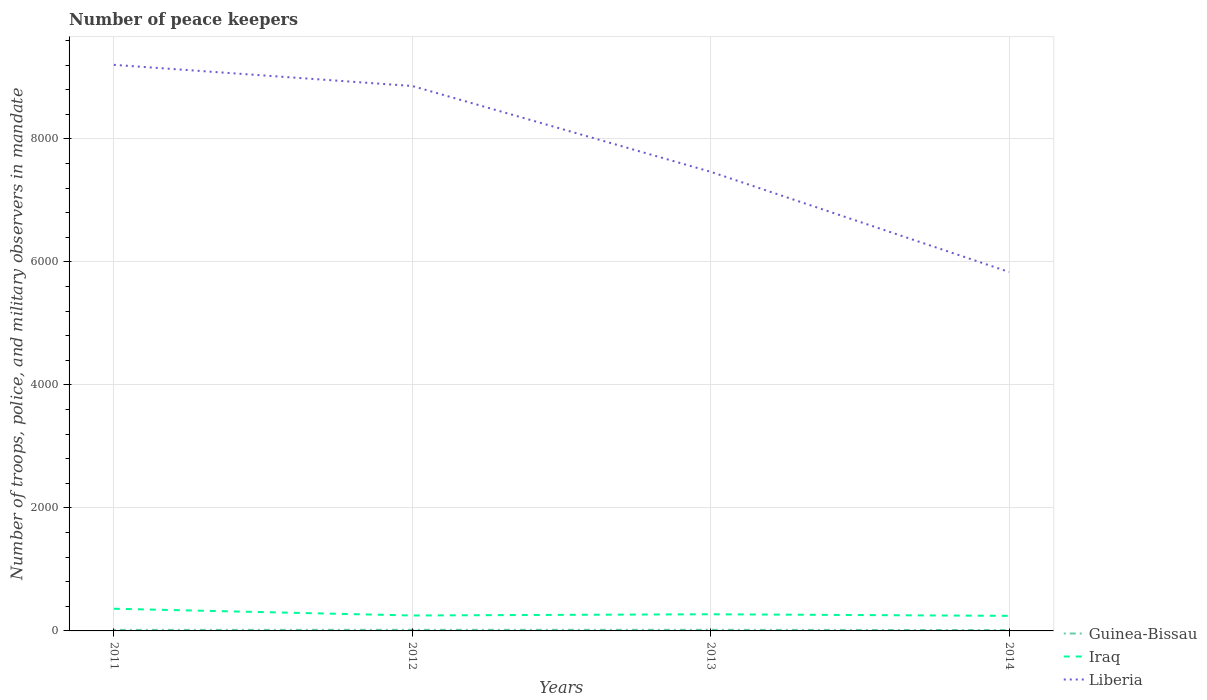Is the number of lines equal to the number of legend labels?
Offer a terse response. Yes. Across all years, what is the maximum number of peace keepers in in Guinea-Bissau?
Ensure brevity in your answer.  14. What is the total number of peace keepers in in Liberia in the graph?
Your answer should be very brief. 1395. What is the difference between the highest and the lowest number of peace keepers in in Liberia?
Provide a short and direct response. 2. How many lines are there?
Your answer should be compact. 3. What is the difference between two consecutive major ticks on the Y-axis?
Provide a short and direct response. 2000. Does the graph contain any zero values?
Ensure brevity in your answer.  No. How are the legend labels stacked?
Your response must be concise. Vertical. What is the title of the graph?
Provide a succinct answer. Number of peace keepers. Does "North America" appear as one of the legend labels in the graph?
Make the answer very short. No. What is the label or title of the X-axis?
Give a very brief answer. Years. What is the label or title of the Y-axis?
Ensure brevity in your answer.  Number of troops, police, and military observers in mandate. What is the Number of troops, police, and military observers in mandate in Iraq in 2011?
Offer a very short reply. 361. What is the Number of troops, police, and military observers in mandate of Liberia in 2011?
Your answer should be compact. 9206. What is the Number of troops, police, and military observers in mandate of Guinea-Bissau in 2012?
Offer a terse response. 18. What is the Number of troops, police, and military observers in mandate of Iraq in 2012?
Give a very brief answer. 251. What is the Number of troops, police, and military observers in mandate in Liberia in 2012?
Make the answer very short. 8862. What is the Number of troops, police, and military observers in mandate in Guinea-Bissau in 2013?
Your response must be concise. 18. What is the Number of troops, police, and military observers in mandate in Iraq in 2013?
Ensure brevity in your answer.  271. What is the Number of troops, police, and military observers in mandate of Liberia in 2013?
Offer a terse response. 7467. What is the Number of troops, police, and military observers in mandate of Iraq in 2014?
Your answer should be compact. 245. What is the Number of troops, police, and military observers in mandate in Liberia in 2014?
Give a very brief answer. 5838. Across all years, what is the maximum Number of troops, police, and military observers in mandate in Iraq?
Give a very brief answer. 361. Across all years, what is the maximum Number of troops, police, and military observers in mandate of Liberia?
Provide a short and direct response. 9206. Across all years, what is the minimum Number of troops, police, and military observers in mandate of Guinea-Bissau?
Your response must be concise. 14. Across all years, what is the minimum Number of troops, police, and military observers in mandate of Iraq?
Provide a short and direct response. 245. Across all years, what is the minimum Number of troops, police, and military observers in mandate of Liberia?
Your response must be concise. 5838. What is the total Number of troops, police, and military observers in mandate in Iraq in the graph?
Give a very brief answer. 1128. What is the total Number of troops, police, and military observers in mandate of Liberia in the graph?
Give a very brief answer. 3.14e+04. What is the difference between the Number of troops, police, and military observers in mandate of Guinea-Bissau in 2011 and that in 2012?
Provide a succinct answer. -1. What is the difference between the Number of troops, police, and military observers in mandate of Iraq in 2011 and that in 2012?
Your answer should be compact. 110. What is the difference between the Number of troops, police, and military observers in mandate in Liberia in 2011 and that in 2012?
Ensure brevity in your answer.  344. What is the difference between the Number of troops, police, and military observers in mandate of Guinea-Bissau in 2011 and that in 2013?
Give a very brief answer. -1. What is the difference between the Number of troops, police, and military observers in mandate in Iraq in 2011 and that in 2013?
Keep it short and to the point. 90. What is the difference between the Number of troops, police, and military observers in mandate in Liberia in 2011 and that in 2013?
Give a very brief answer. 1739. What is the difference between the Number of troops, police, and military observers in mandate in Guinea-Bissau in 2011 and that in 2014?
Keep it short and to the point. 3. What is the difference between the Number of troops, police, and military observers in mandate in Iraq in 2011 and that in 2014?
Your answer should be very brief. 116. What is the difference between the Number of troops, police, and military observers in mandate in Liberia in 2011 and that in 2014?
Your answer should be very brief. 3368. What is the difference between the Number of troops, police, and military observers in mandate in Iraq in 2012 and that in 2013?
Offer a terse response. -20. What is the difference between the Number of troops, police, and military observers in mandate of Liberia in 2012 and that in 2013?
Your answer should be compact. 1395. What is the difference between the Number of troops, police, and military observers in mandate in Guinea-Bissau in 2012 and that in 2014?
Keep it short and to the point. 4. What is the difference between the Number of troops, police, and military observers in mandate of Iraq in 2012 and that in 2014?
Offer a terse response. 6. What is the difference between the Number of troops, police, and military observers in mandate in Liberia in 2012 and that in 2014?
Make the answer very short. 3024. What is the difference between the Number of troops, police, and military observers in mandate in Guinea-Bissau in 2013 and that in 2014?
Give a very brief answer. 4. What is the difference between the Number of troops, police, and military observers in mandate in Liberia in 2013 and that in 2014?
Ensure brevity in your answer.  1629. What is the difference between the Number of troops, police, and military observers in mandate of Guinea-Bissau in 2011 and the Number of troops, police, and military observers in mandate of Iraq in 2012?
Provide a short and direct response. -234. What is the difference between the Number of troops, police, and military observers in mandate of Guinea-Bissau in 2011 and the Number of troops, police, and military observers in mandate of Liberia in 2012?
Provide a succinct answer. -8845. What is the difference between the Number of troops, police, and military observers in mandate in Iraq in 2011 and the Number of troops, police, and military observers in mandate in Liberia in 2012?
Offer a very short reply. -8501. What is the difference between the Number of troops, police, and military observers in mandate in Guinea-Bissau in 2011 and the Number of troops, police, and military observers in mandate in Iraq in 2013?
Provide a succinct answer. -254. What is the difference between the Number of troops, police, and military observers in mandate in Guinea-Bissau in 2011 and the Number of troops, police, and military observers in mandate in Liberia in 2013?
Offer a terse response. -7450. What is the difference between the Number of troops, police, and military observers in mandate of Iraq in 2011 and the Number of troops, police, and military observers in mandate of Liberia in 2013?
Make the answer very short. -7106. What is the difference between the Number of troops, police, and military observers in mandate of Guinea-Bissau in 2011 and the Number of troops, police, and military observers in mandate of Iraq in 2014?
Your answer should be very brief. -228. What is the difference between the Number of troops, police, and military observers in mandate of Guinea-Bissau in 2011 and the Number of troops, police, and military observers in mandate of Liberia in 2014?
Keep it short and to the point. -5821. What is the difference between the Number of troops, police, and military observers in mandate in Iraq in 2011 and the Number of troops, police, and military observers in mandate in Liberia in 2014?
Give a very brief answer. -5477. What is the difference between the Number of troops, police, and military observers in mandate of Guinea-Bissau in 2012 and the Number of troops, police, and military observers in mandate of Iraq in 2013?
Ensure brevity in your answer.  -253. What is the difference between the Number of troops, police, and military observers in mandate of Guinea-Bissau in 2012 and the Number of troops, police, and military observers in mandate of Liberia in 2013?
Make the answer very short. -7449. What is the difference between the Number of troops, police, and military observers in mandate of Iraq in 2012 and the Number of troops, police, and military observers in mandate of Liberia in 2013?
Your answer should be compact. -7216. What is the difference between the Number of troops, police, and military observers in mandate in Guinea-Bissau in 2012 and the Number of troops, police, and military observers in mandate in Iraq in 2014?
Provide a short and direct response. -227. What is the difference between the Number of troops, police, and military observers in mandate in Guinea-Bissau in 2012 and the Number of troops, police, and military observers in mandate in Liberia in 2014?
Ensure brevity in your answer.  -5820. What is the difference between the Number of troops, police, and military observers in mandate of Iraq in 2012 and the Number of troops, police, and military observers in mandate of Liberia in 2014?
Your answer should be compact. -5587. What is the difference between the Number of troops, police, and military observers in mandate of Guinea-Bissau in 2013 and the Number of troops, police, and military observers in mandate of Iraq in 2014?
Give a very brief answer. -227. What is the difference between the Number of troops, police, and military observers in mandate of Guinea-Bissau in 2013 and the Number of troops, police, and military observers in mandate of Liberia in 2014?
Provide a short and direct response. -5820. What is the difference between the Number of troops, police, and military observers in mandate in Iraq in 2013 and the Number of troops, police, and military observers in mandate in Liberia in 2014?
Give a very brief answer. -5567. What is the average Number of troops, police, and military observers in mandate in Guinea-Bissau per year?
Keep it short and to the point. 16.75. What is the average Number of troops, police, and military observers in mandate of Iraq per year?
Keep it short and to the point. 282. What is the average Number of troops, police, and military observers in mandate of Liberia per year?
Provide a succinct answer. 7843.25. In the year 2011, what is the difference between the Number of troops, police, and military observers in mandate in Guinea-Bissau and Number of troops, police, and military observers in mandate in Iraq?
Your answer should be compact. -344. In the year 2011, what is the difference between the Number of troops, police, and military observers in mandate of Guinea-Bissau and Number of troops, police, and military observers in mandate of Liberia?
Your answer should be very brief. -9189. In the year 2011, what is the difference between the Number of troops, police, and military observers in mandate of Iraq and Number of troops, police, and military observers in mandate of Liberia?
Offer a very short reply. -8845. In the year 2012, what is the difference between the Number of troops, police, and military observers in mandate of Guinea-Bissau and Number of troops, police, and military observers in mandate of Iraq?
Your response must be concise. -233. In the year 2012, what is the difference between the Number of troops, police, and military observers in mandate of Guinea-Bissau and Number of troops, police, and military observers in mandate of Liberia?
Make the answer very short. -8844. In the year 2012, what is the difference between the Number of troops, police, and military observers in mandate in Iraq and Number of troops, police, and military observers in mandate in Liberia?
Keep it short and to the point. -8611. In the year 2013, what is the difference between the Number of troops, police, and military observers in mandate in Guinea-Bissau and Number of troops, police, and military observers in mandate in Iraq?
Keep it short and to the point. -253. In the year 2013, what is the difference between the Number of troops, police, and military observers in mandate of Guinea-Bissau and Number of troops, police, and military observers in mandate of Liberia?
Your answer should be very brief. -7449. In the year 2013, what is the difference between the Number of troops, police, and military observers in mandate in Iraq and Number of troops, police, and military observers in mandate in Liberia?
Your answer should be compact. -7196. In the year 2014, what is the difference between the Number of troops, police, and military observers in mandate of Guinea-Bissau and Number of troops, police, and military observers in mandate of Iraq?
Offer a terse response. -231. In the year 2014, what is the difference between the Number of troops, police, and military observers in mandate of Guinea-Bissau and Number of troops, police, and military observers in mandate of Liberia?
Make the answer very short. -5824. In the year 2014, what is the difference between the Number of troops, police, and military observers in mandate of Iraq and Number of troops, police, and military observers in mandate of Liberia?
Provide a short and direct response. -5593. What is the ratio of the Number of troops, police, and military observers in mandate in Iraq in 2011 to that in 2012?
Offer a very short reply. 1.44. What is the ratio of the Number of troops, police, and military observers in mandate of Liberia in 2011 to that in 2012?
Your answer should be compact. 1.04. What is the ratio of the Number of troops, police, and military observers in mandate of Iraq in 2011 to that in 2013?
Keep it short and to the point. 1.33. What is the ratio of the Number of troops, police, and military observers in mandate in Liberia in 2011 to that in 2013?
Offer a very short reply. 1.23. What is the ratio of the Number of troops, police, and military observers in mandate of Guinea-Bissau in 2011 to that in 2014?
Make the answer very short. 1.21. What is the ratio of the Number of troops, police, and military observers in mandate in Iraq in 2011 to that in 2014?
Your answer should be compact. 1.47. What is the ratio of the Number of troops, police, and military observers in mandate in Liberia in 2011 to that in 2014?
Keep it short and to the point. 1.58. What is the ratio of the Number of troops, police, and military observers in mandate of Iraq in 2012 to that in 2013?
Offer a terse response. 0.93. What is the ratio of the Number of troops, police, and military observers in mandate of Liberia in 2012 to that in 2013?
Make the answer very short. 1.19. What is the ratio of the Number of troops, police, and military observers in mandate in Iraq in 2012 to that in 2014?
Give a very brief answer. 1.02. What is the ratio of the Number of troops, police, and military observers in mandate in Liberia in 2012 to that in 2014?
Offer a very short reply. 1.52. What is the ratio of the Number of troops, police, and military observers in mandate in Iraq in 2013 to that in 2014?
Offer a terse response. 1.11. What is the ratio of the Number of troops, police, and military observers in mandate of Liberia in 2013 to that in 2014?
Make the answer very short. 1.28. What is the difference between the highest and the second highest Number of troops, police, and military observers in mandate in Guinea-Bissau?
Your answer should be compact. 0. What is the difference between the highest and the second highest Number of troops, police, and military observers in mandate in Iraq?
Offer a terse response. 90. What is the difference between the highest and the second highest Number of troops, police, and military observers in mandate in Liberia?
Your answer should be compact. 344. What is the difference between the highest and the lowest Number of troops, police, and military observers in mandate of Iraq?
Your answer should be compact. 116. What is the difference between the highest and the lowest Number of troops, police, and military observers in mandate of Liberia?
Ensure brevity in your answer.  3368. 